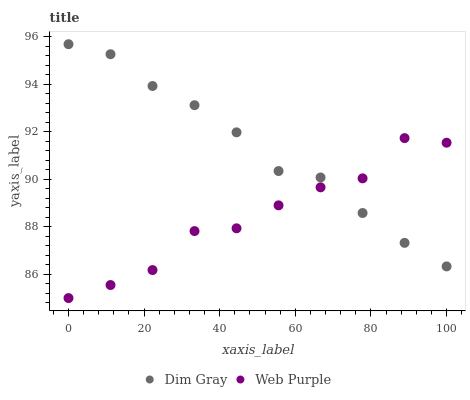Does Web Purple have the minimum area under the curve?
Answer yes or no. Yes. Does Dim Gray have the maximum area under the curve?
Answer yes or no. Yes. Does Dim Gray have the minimum area under the curve?
Answer yes or no. No. Is Dim Gray the smoothest?
Answer yes or no. Yes. Is Web Purple the roughest?
Answer yes or no. Yes. Is Dim Gray the roughest?
Answer yes or no. No. Does Web Purple have the lowest value?
Answer yes or no. Yes. Does Dim Gray have the lowest value?
Answer yes or no. No. Does Dim Gray have the highest value?
Answer yes or no. Yes. Does Dim Gray intersect Web Purple?
Answer yes or no. Yes. Is Dim Gray less than Web Purple?
Answer yes or no. No. Is Dim Gray greater than Web Purple?
Answer yes or no. No. 